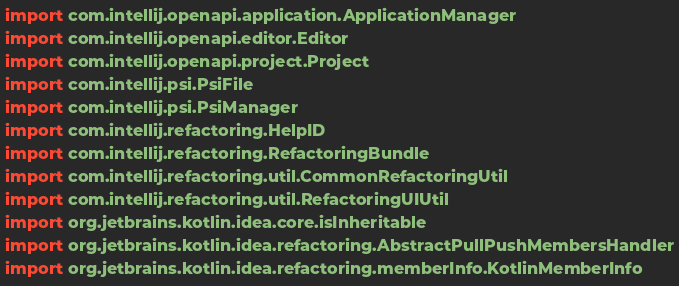Convert code to text. <code><loc_0><loc_0><loc_500><loc_500><_Kotlin_>import com.intellij.openapi.application.ApplicationManager
import com.intellij.openapi.editor.Editor
import com.intellij.openapi.project.Project
import com.intellij.psi.PsiFile
import com.intellij.psi.PsiManager
import com.intellij.refactoring.HelpID
import com.intellij.refactoring.RefactoringBundle
import com.intellij.refactoring.util.CommonRefactoringUtil
import com.intellij.refactoring.util.RefactoringUIUtil
import org.jetbrains.kotlin.idea.core.isInheritable
import org.jetbrains.kotlin.idea.refactoring.AbstractPullPushMembersHandler
import org.jetbrains.kotlin.idea.refactoring.memberInfo.KotlinMemberInfo</code> 